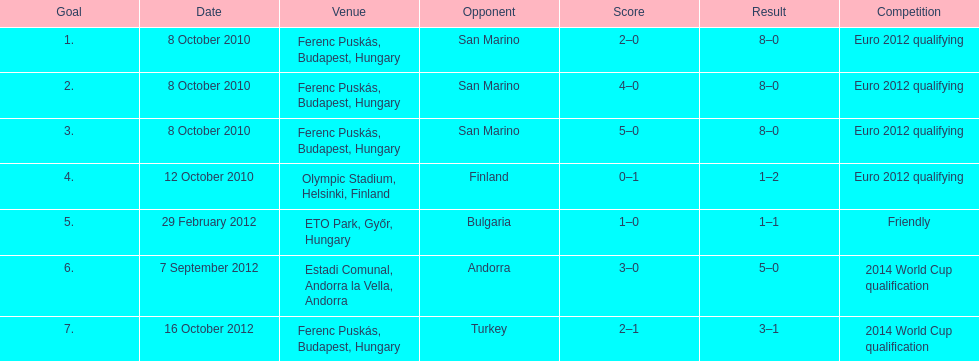What is the complete sum of international goals ádám szalai has achieved? 7. 